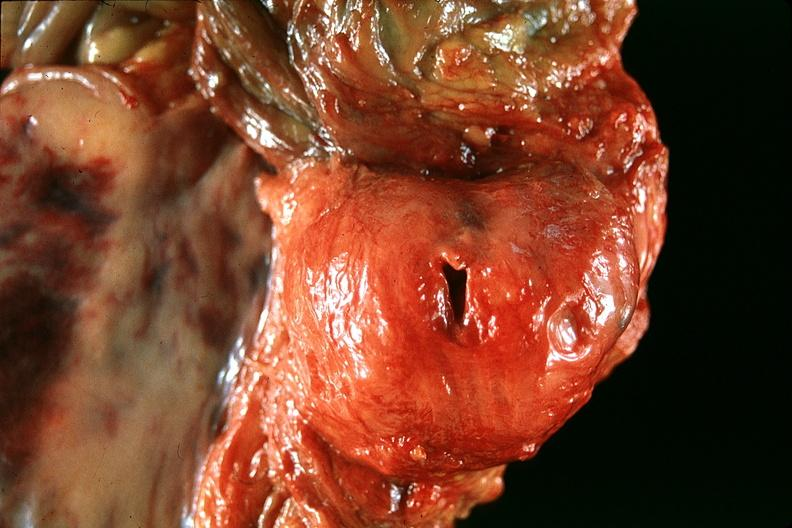what does this image show?
Answer the question using a single word or phrase. Normal prostate 